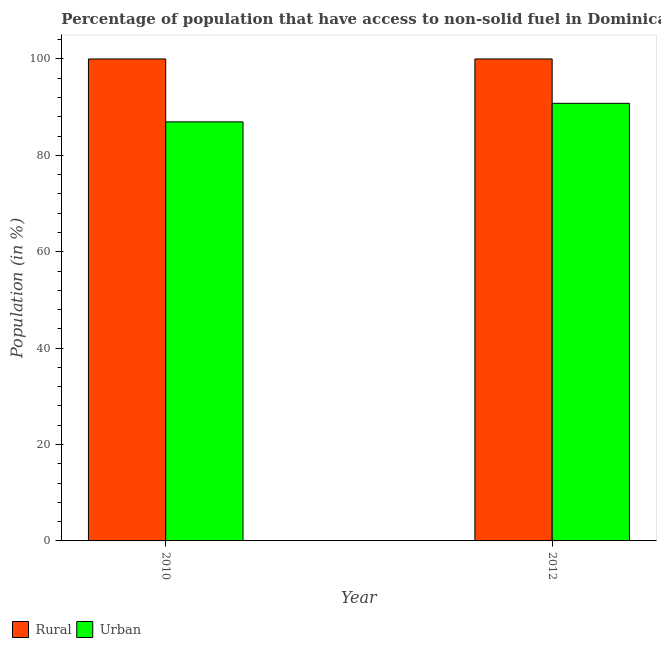How many groups of bars are there?
Ensure brevity in your answer.  2. Are the number of bars per tick equal to the number of legend labels?
Your answer should be very brief. Yes. Are the number of bars on each tick of the X-axis equal?
Provide a succinct answer. Yes. How many bars are there on the 1st tick from the left?
Ensure brevity in your answer.  2. What is the urban population in 2012?
Your response must be concise. 90.8. Across all years, what is the maximum urban population?
Make the answer very short. 90.8. Across all years, what is the minimum rural population?
Provide a succinct answer. 100. In which year was the urban population maximum?
Provide a succinct answer. 2012. In which year was the rural population minimum?
Ensure brevity in your answer.  2010. What is the total rural population in the graph?
Give a very brief answer. 200. What is the difference between the urban population in 2010 and that in 2012?
Give a very brief answer. -3.85. What is the difference between the rural population in 2012 and the urban population in 2010?
Offer a terse response. 0. What is the average urban population per year?
Your response must be concise. 88.87. In the year 2010, what is the difference between the urban population and rural population?
Your answer should be compact. 0. In how many years, is the urban population greater than 20 %?
Offer a very short reply. 2. What is the ratio of the urban population in 2010 to that in 2012?
Your answer should be very brief. 0.96. Is the urban population in 2010 less than that in 2012?
Offer a terse response. Yes. What does the 2nd bar from the left in 2012 represents?
Provide a succinct answer. Urban. What does the 2nd bar from the right in 2012 represents?
Offer a terse response. Rural. How many bars are there?
Your response must be concise. 4. Are all the bars in the graph horizontal?
Provide a succinct answer. No. How many years are there in the graph?
Offer a very short reply. 2. What is the difference between two consecutive major ticks on the Y-axis?
Your response must be concise. 20. Are the values on the major ticks of Y-axis written in scientific E-notation?
Your response must be concise. No. Does the graph contain any zero values?
Give a very brief answer. No. What is the title of the graph?
Your response must be concise. Percentage of population that have access to non-solid fuel in Dominica. What is the label or title of the X-axis?
Provide a succinct answer. Year. What is the Population (in %) of Urban in 2010?
Your answer should be compact. 86.95. What is the Population (in %) in Rural in 2012?
Give a very brief answer. 100. What is the Population (in %) of Urban in 2012?
Provide a succinct answer. 90.8. Across all years, what is the maximum Population (in %) of Urban?
Provide a succinct answer. 90.8. Across all years, what is the minimum Population (in %) of Urban?
Your response must be concise. 86.95. What is the total Population (in %) of Rural in the graph?
Make the answer very short. 200. What is the total Population (in %) in Urban in the graph?
Offer a very short reply. 177.75. What is the difference between the Population (in %) in Urban in 2010 and that in 2012?
Keep it short and to the point. -3.85. What is the difference between the Population (in %) of Rural in 2010 and the Population (in %) of Urban in 2012?
Offer a very short reply. 9.2. What is the average Population (in %) of Rural per year?
Keep it short and to the point. 100. What is the average Population (in %) of Urban per year?
Your answer should be very brief. 88.87. In the year 2010, what is the difference between the Population (in %) of Rural and Population (in %) of Urban?
Give a very brief answer. 13.05. In the year 2012, what is the difference between the Population (in %) of Rural and Population (in %) of Urban?
Your response must be concise. 9.2. What is the ratio of the Population (in %) of Urban in 2010 to that in 2012?
Your response must be concise. 0.96. What is the difference between the highest and the second highest Population (in %) in Rural?
Make the answer very short. 0. What is the difference between the highest and the second highest Population (in %) in Urban?
Provide a succinct answer. 3.85. What is the difference between the highest and the lowest Population (in %) in Urban?
Make the answer very short. 3.85. 